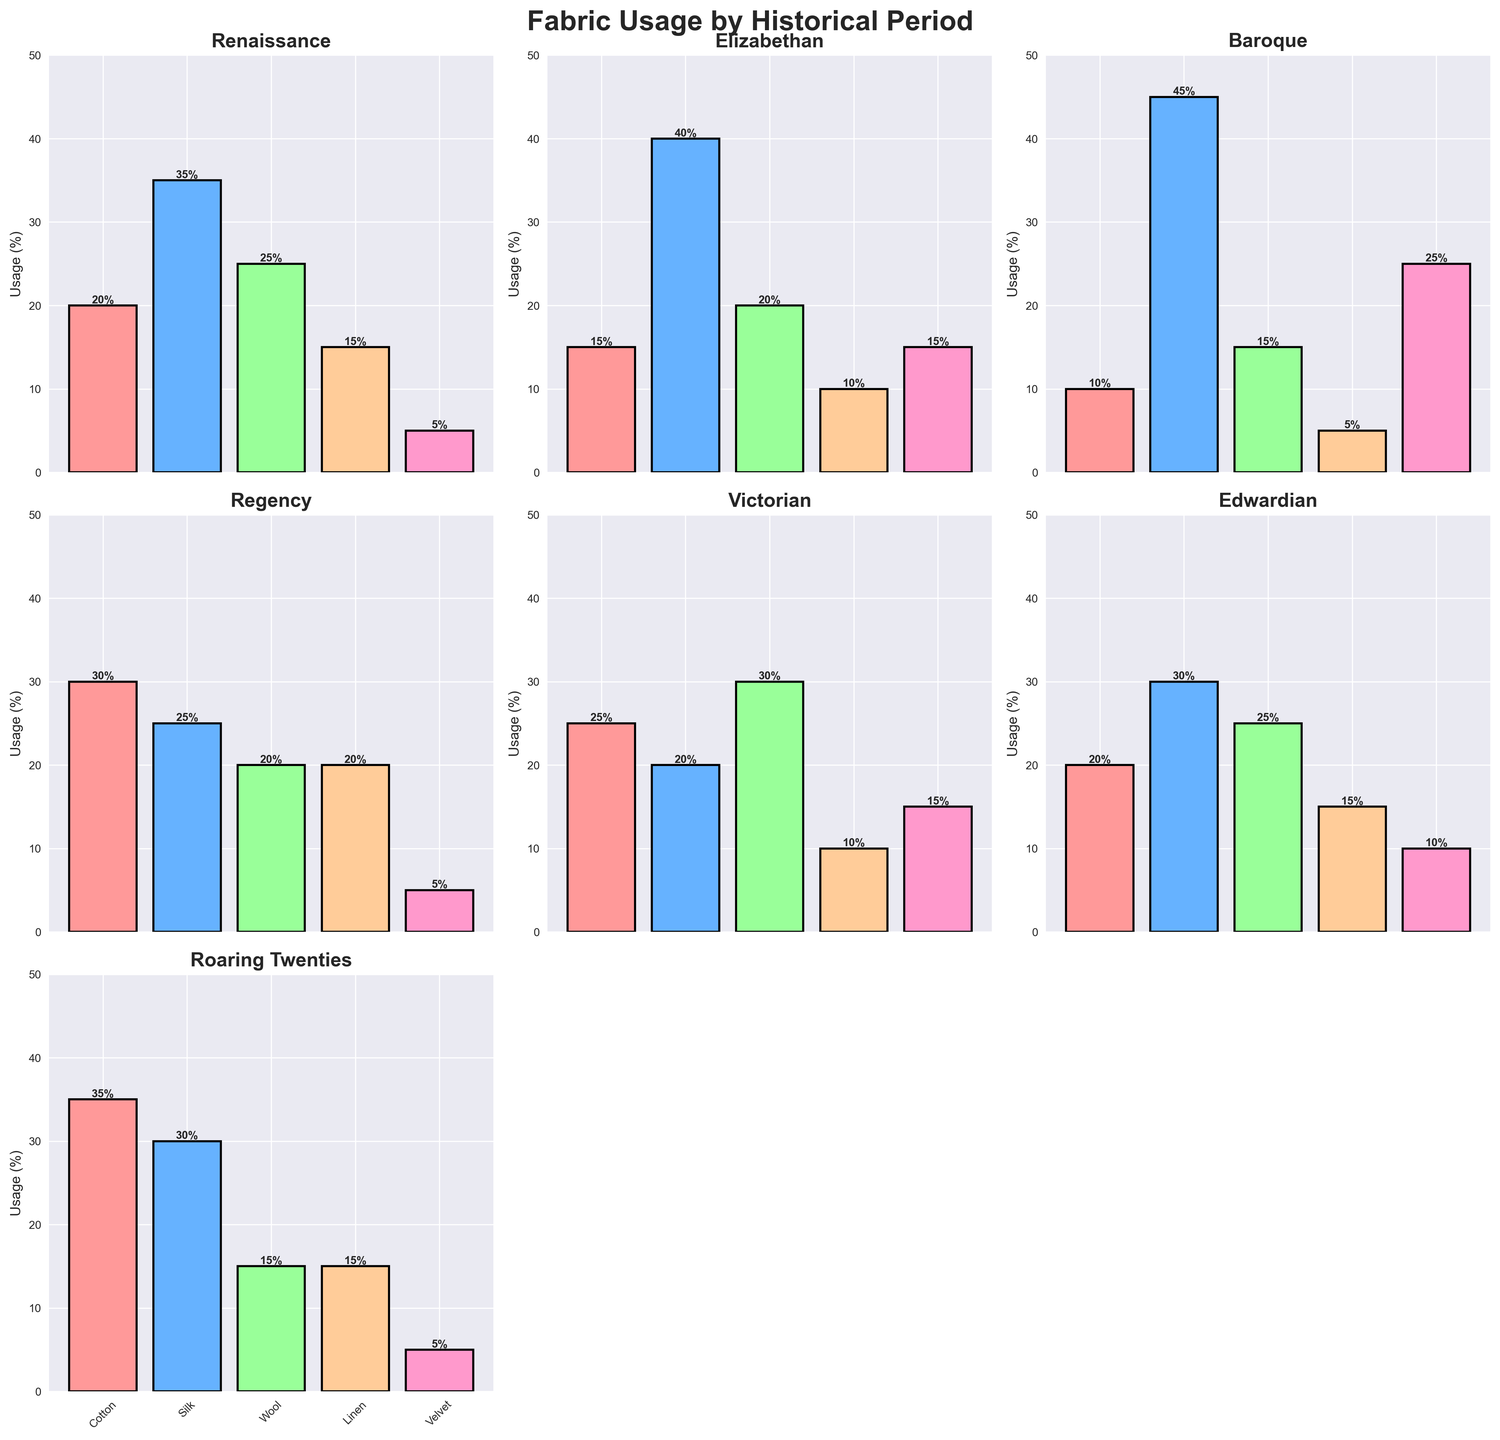What historical period uses the most Silk? Look at each subplot title and find the tallest bar for Silk. The Baroque period shows the highest bar for Silk.
Answer: Baroque Which fabric has the lowest usage during the Baroque period? Find the subplot titled "Baroque" and identify the shortest bar. Linen is the shortest bar.
Answer: Linen What is the sum of Cotton usage across all periods? Add up the Cotton values from all periods: 20 + 15 + 10 + 30 + 25 + 20 + 35 = 155
Answer: 155 How does the usage of Velvet in the Victorian period compare to the Elizabethan period? Locate the Victorian subplot and the Elizabethan subplot, compare the height of Velvet bars. Both are 15%.
Answer: Equal Which two periods have the same percentage of Linen usage? Look at each subplot to see which two periods have Linen bars of the same height. Both Renaissance and Edwardian subplots show Linen usage at 15%.
Answer: Renaissance and Edwardian During the Edwardian period, which fabric exceeds 25% usage? Locate the Edwardian period subplot and find any bar that exceeds 25%. Silk usage is 30%.
Answer: Silk What is the average Wool usage percentage across the periods? Add Wool usage for all periods and divide by the number of periods: (25 + 20 + 15 + 20 + 30 + 25 + 15) / 7 = 21.43%
Answer: 21.43% In the Regency period, how much more percentage is Cotton used compared to Velvet? Locate the Regency period subplot, and subtract the Velvet percentage from the Cotton percentage: 30 - 5 = 25%
Answer: 25% Which fabric has a decreasing trend in usage from the Baroque to the Edwardian period? Compare the heights of bars across Baroque, Regency, Victorian, and Edwardian for each fabric. Wool decreases from 15% (Baroque) to 25% (Edwardian), which is not a decreasing trend. Velvet shows a decreasing trend.
Answer: Velvet 